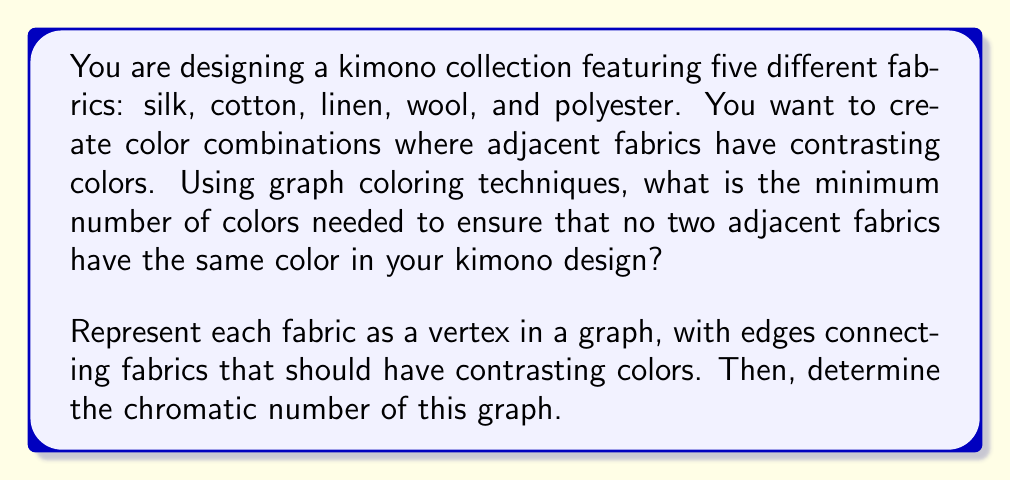Help me with this question. To solve this problem, we'll follow these steps:

1. Create a graph representation:
   - Each fabric type (silk, cotton, linen, wool, polyester) is a vertex.
   - Connect vertices (fabrics) that should have contrasting colors with edges.

2. Analyze the graph structure:
   The resulting graph is a complete graph $K_5$, as each fabric needs to contrast with every other fabric.

3. Determine the chromatic number:
   For a complete graph $K_n$, the chromatic number $\chi(K_n) = n$.

   In this case, $\chi(K_5) = 5$.

[asy]
import graph;

size(200);

pair[] v = {
  dir(90),
  dir(18),
  dir(-54),
  dir(-126),
  dir(162)
};

for (int i = 0; i < 5; ++i)
  for (int j = i + 1; j < 5; ++j)
    draw(v[i]--v[j]);

dot(v[0], red);
dot(v[1], blue);
dot(v[2], green);
dot(v[3], yellow);
dot(v[4], purple);

label("Silk", v[0], N);
label("Cotton", v[1], NE);
label("Linen", v[2], SE);
label("Wool", v[3], SW);
label("Polyester", v[4], NW);
[/asy]

The graph coloring theorem states that the minimum number of colors needed to color a graph so that no two adjacent vertices have the same color is equal to the chromatic number of the graph.

In this case, we need 5 colors to ensure that each fabric has a unique color different from all others, as every fabric needs to contrast with every other fabric in the kimono design.
Answer: The minimum number of colors needed is 5. 